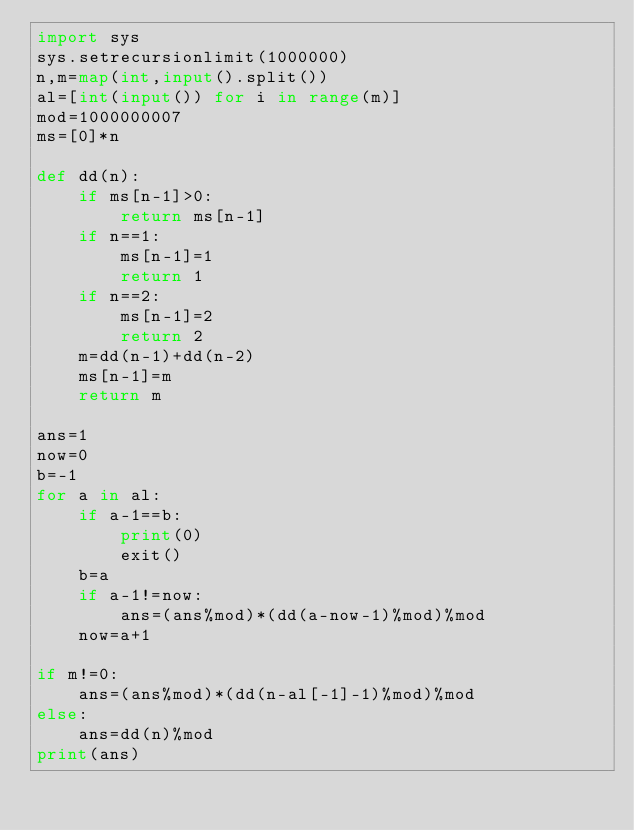<code> <loc_0><loc_0><loc_500><loc_500><_Python_>import sys
sys.setrecursionlimit(1000000)
n,m=map(int,input().split())
al=[int(input()) for i in range(m)]
mod=1000000007
ms=[0]*n

def dd(n):
    if ms[n-1]>0:
        return ms[n-1]
    if n==1:
        ms[n-1]=1
        return 1
    if n==2:
        ms[n-1]=2
        return 2
    m=dd(n-1)+dd(n-2)
    ms[n-1]=m
    return m

ans=1
now=0
b=-1
for a in al:
    if a-1==b:
        print(0)
        exit()
    b=a
    if a-1!=now:
        ans=(ans%mod)*(dd(a-now-1)%mod)%mod
    now=a+1

if m!=0:
    ans=(ans%mod)*(dd(n-al[-1]-1)%mod)%mod
else:
    ans=dd(n)%mod
print(ans)</code> 